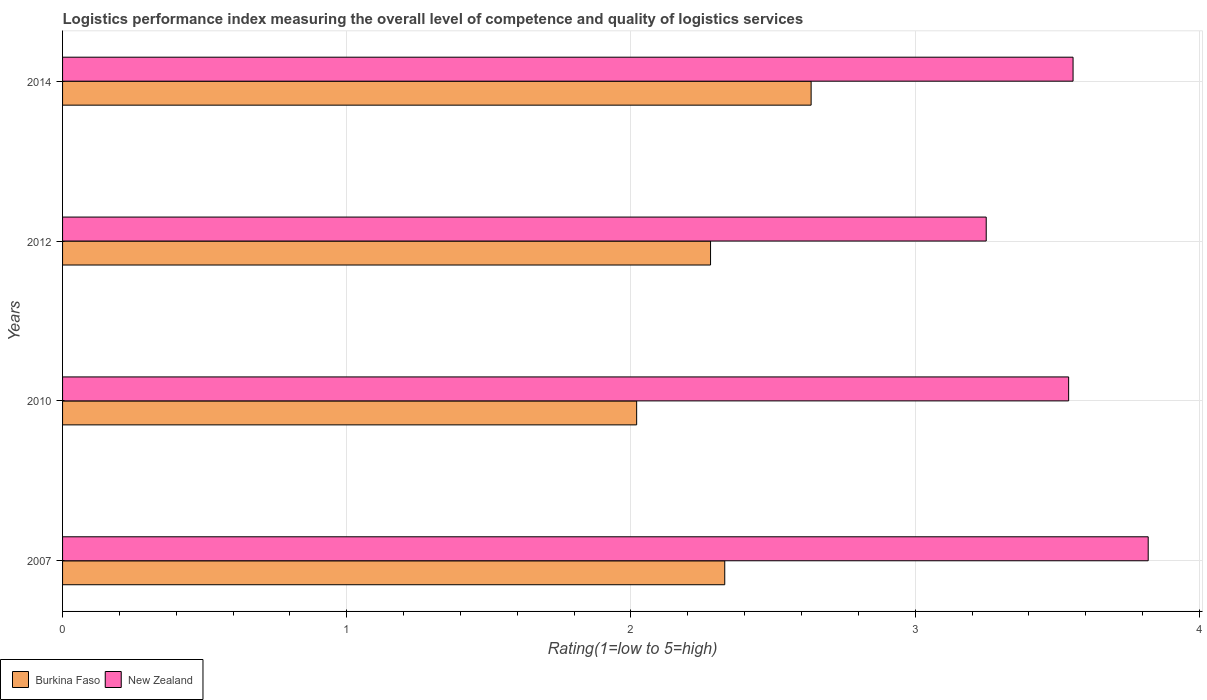How many different coloured bars are there?
Your response must be concise. 2. How many groups of bars are there?
Keep it short and to the point. 4. How many bars are there on the 3rd tick from the bottom?
Keep it short and to the point. 2. What is the label of the 2nd group of bars from the top?
Make the answer very short. 2012. In how many cases, is the number of bars for a given year not equal to the number of legend labels?
Your answer should be very brief. 0. What is the Logistic performance index in Burkina Faso in 2012?
Make the answer very short. 2.28. Across all years, what is the maximum Logistic performance index in New Zealand?
Offer a terse response. 3.82. In which year was the Logistic performance index in New Zealand minimum?
Provide a succinct answer. 2012. What is the total Logistic performance index in New Zealand in the graph?
Ensure brevity in your answer.  14.17. What is the difference between the Logistic performance index in Burkina Faso in 2010 and that in 2012?
Your response must be concise. -0.26. What is the difference between the Logistic performance index in Burkina Faso in 2014 and the Logistic performance index in New Zealand in 2012?
Give a very brief answer. -0.62. What is the average Logistic performance index in Burkina Faso per year?
Provide a short and direct response. 2.32. In the year 2007, what is the difference between the Logistic performance index in Burkina Faso and Logistic performance index in New Zealand?
Your answer should be compact. -1.49. What is the ratio of the Logistic performance index in New Zealand in 2007 to that in 2014?
Your answer should be compact. 1.07. What is the difference between the highest and the second highest Logistic performance index in Burkina Faso?
Provide a short and direct response. 0.3. What is the difference between the highest and the lowest Logistic performance index in New Zealand?
Your response must be concise. 0.57. Is the sum of the Logistic performance index in Burkina Faso in 2010 and 2014 greater than the maximum Logistic performance index in New Zealand across all years?
Provide a succinct answer. Yes. What does the 1st bar from the top in 2012 represents?
Ensure brevity in your answer.  New Zealand. What does the 1st bar from the bottom in 2010 represents?
Make the answer very short. Burkina Faso. How many bars are there?
Your answer should be very brief. 8. Are all the bars in the graph horizontal?
Offer a very short reply. Yes. How many years are there in the graph?
Your response must be concise. 4. What is the difference between two consecutive major ticks on the X-axis?
Ensure brevity in your answer.  1. Where does the legend appear in the graph?
Provide a short and direct response. Bottom left. How are the legend labels stacked?
Provide a short and direct response. Horizontal. What is the title of the graph?
Offer a very short reply. Logistics performance index measuring the overall level of competence and quality of logistics services. What is the label or title of the X-axis?
Ensure brevity in your answer.  Rating(1=low to 5=high). What is the label or title of the Y-axis?
Keep it short and to the point. Years. What is the Rating(1=low to 5=high) of Burkina Faso in 2007?
Keep it short and to the point. 2.33. What is the Rating(1=low to 5=high) in New Zealand in 2007?
Keep it short and to the point. 3.82. What is the Rating(1=low to 5=high) of Burkina Faso in 2010?
Keep it short and to the point. 2.02. What is the Rating(1=low to 5=high) in New Zealand in 2010?
Your response must be concise. 3.54. What is the Rating(1=low to 5=high) in Burkina Faso in 2012?
Offer a very short reply. 2.28. What is the Rating(1=low to 5=high) in New Zealand in 2012?
Offer a terse response. 3.25. What is the Rating(1=low to 5=high) in Burkina Faso in 2014?
Make the answer very short. 2.63. What is the Rating(1=low to 5=high) of New Zealand in 2014?
Make the answer very short. 3.56. Across all years, what is the maximum Rating(1=low to 5=high) of Burkina Faso?
Offer a terse response. 2.63. Across all years, what is the maximum Rating(1=low to 5=high) in New Zealand?
Make the answer very short. 3.82. Across all years, what is the minimum Rating(1=low to 5=high) in Burkina Faso?
Your answer should be very brief. 2.02. Across all years, what is the minimum Rating(1=low to 5=high) of New Zealand?
Provide a short and direct response. 3.25. What is the total Rating(1=low to 5=high) in Burkina Faso in the graph?
Provide a short and direct response. 9.26. What is the total Rating(1=low to 5=high) of New Zealand in the graph?
Make the answer very short. 14.17. What is the difference between the Rating(1=low to 5=high) in Burkina Faso in 2007 and that in 2010?
Offer a terse response. 0.31. What is the difference between the Rating(1=low to 5=high) of New Zealand in 2007 and that in 2010?
Provide a short and direct response. 0.28. What is the difference between the Rating(1=low to 5=high) in Burkina Faso in 2007 and that in 2012?
Offer a terse response. 0.05. What is the difference between the Rating(1=low to 5=high) in New Zealand in 2007 and that in 2012?
Provide a short and direct response. 0.57. What is the difference between the Rating(1=low to 5=high) of Burkina Faso in 2007 and that in 2014?
Your answer should be compact. -0.3. What is the difference between the Rating(1=low to 5=high) of New Zealand in 2007 and that in 2014?
Your answer should be compact. 0.26. What is the difference between the Rating(1=low to 5=high) in Burkina Faso in 2010 and that in 2012?
Offer a terse response. -0.26. What is the difference between the Rating(1=low to 5=high) of New Zealand in 2010 and that in 2012?
Keep it short and to the point. 0.29. What is the difference between the Rating(1=low to 5=high) in Burkina Faso in 2010 and that in 2014?
Ensure brevity in your answer.  -0.61. What is the difference between the Rating(1=low to 5=high) in New Zealand in 2010 and that in 2014?
Offer a terse response. -0.02. What is the difference between the Rating(1=low to 5=high) in Burkina Faso in 2012 and that in 2014?
Offer a terse response. -0.35. What is the difference between the Rating(1=low to 5=high) in New Zealand in 2012 and that in 2014?
Make the answer very short. -0.31. What is the difference between the Rating(1=low to 5=high) in Burkina Faso in 2007 and the Rating(1=low to 5=high) in New Zealand in 2010?
Offer a terse response. -1.21. What is the difference between the Rating(1=low to 5=high) in Burkina Faso in 2007 and the Rating(1=low to 5=high) in New Zealand in 2012?
Keep it short and to the point. -0.92. What is the difference between the Rating(1=low to 5=high) of Burkina Faso in 2007 and the Rating(1=low to 5=high) of New Zealand in 2014?
Offer a terse response. -1.23. What is the difference between the Rating(1=low to 5=high) in Burkina Faso in 2010 and the Rating(1=low to 5=high) in New Zealand in 2012?
Give a very brief answer. -1.23. What is the difference between the Rating(1=low to 5=high) of Burkina Faso in 2010 and the Rating(1=low to 5=high) of New Zealand in 2014?
Keep it short and to the point. -1.54. What is the difference between the Rating(1=low to 5=high) in Burkina Faso in 2012 and the Rating(1=low to 5=high) in New Zealand in 2014?
Make the answer very short. -1.28. What is the average Rating(1=low to 5=high) in Burkina Faso per year?
Make the answer very short. 2.32. What is the average Rating(1=low to 5=high) in New Zealand per year?
Offer a terse response. 3.54. In the year 2007, what is the difference between the Rating(1=low to 5=high) of Burkina Faso and Rating(1=low to 5=high) of New Zealand?
Offer a very short reply. -1.49. In the year 2010, what is the difference between the Rating(1=low to 5=high) in Burkina Faso and Rating(1=low to 5=high) in New Zealand?
Your response must be concise. -1.52. In the year 2012, what is the difference between the Rating(1=low to 5=high) in Burkina Faso and Rating(1=low to 5=high) in New Zealand?
Ensure brevity in your answer.  -0.97. In the year 2014, what is the difference between the Rating(1=low to 5=high) of Burkina Faso and Rating(1=low to 5=high) of New Zealand?
Ensure brevity in your answer.  -0.92. What is the ratio of the Rating(1=low to 5=high) in Burkina Faso in 2007 to that in 2010?
Make the answer very short. 1.15. What is the ratio of the Rating(1=low to 5=high) of New Zealand in 2007 to that in 2010?
Provide a succinct answer. 1.08. What is the ratio of the Rating(1=low to 5=high) in Burkina Faso in 2007 to that in 2012?
Provide a succinct answer. 1.02. What is the ratio of the Rating(1=low to 5=high) in New Zealand in 2007 to that in 2012?
Your answer should be compact. 1.18. What is the ratio of the Rating(1=low to 5=high) of Burkina Faso in 2007 to that in 2014?
Your response must be concise. 0.88. What is the ratio of the Rating(1=low to 5=high) of New Zealand in 2007 to that in 2014?
Ensure brevity in your answer.  1.07. What is the ratio of the Rating(1=low to 5=high) in Burkina Faso in 2010 to that in 2012?
Make the answer very short. 0.89. What is the ratio of the Rating(1=low to 5=high) in New Zealand in 2010 to that in 2012?
Your response must be concise. 1.09. What is the ratio of the Rating(1=low to 5=high) in Burkina Faso in 2010 to that in 2014?
Keep it short and to the point. 0.77. What is the ratio of the Rating(1=low to 5=high) of New Zealand in 2010 to that in 2014?
Your answer should be very brief. 1. What is the ratio of the Rating(1=low to 5=high) in Burkina Faso in 2012 to that in 2014?
Your answer should be compact. 0.87. What is the ratio of the Rating(1=low to 5=high) of New Zealand in 2012 to that in 2014?
Ensure brevity in your answer.  0.91. What is the difference between the highest and the second highest Rating(1=low to 5=high) in Burkina Faso?
Ensure brevity in your answer.  0.3. What is the difference between the highest and the second highest Rating(1=low to 5=high) of New Zealand?
Your answer should be very brief. 0.26. What is the difference between the highest and the lowest Rating(1=low to 5=high) of Burkina Faso?
Provide a short and direct response. 0.61. What is the difference between the highest and the lowest Rating(1=low to 5=high) in New Zealand?
Give a very brief answer. 0.57. 